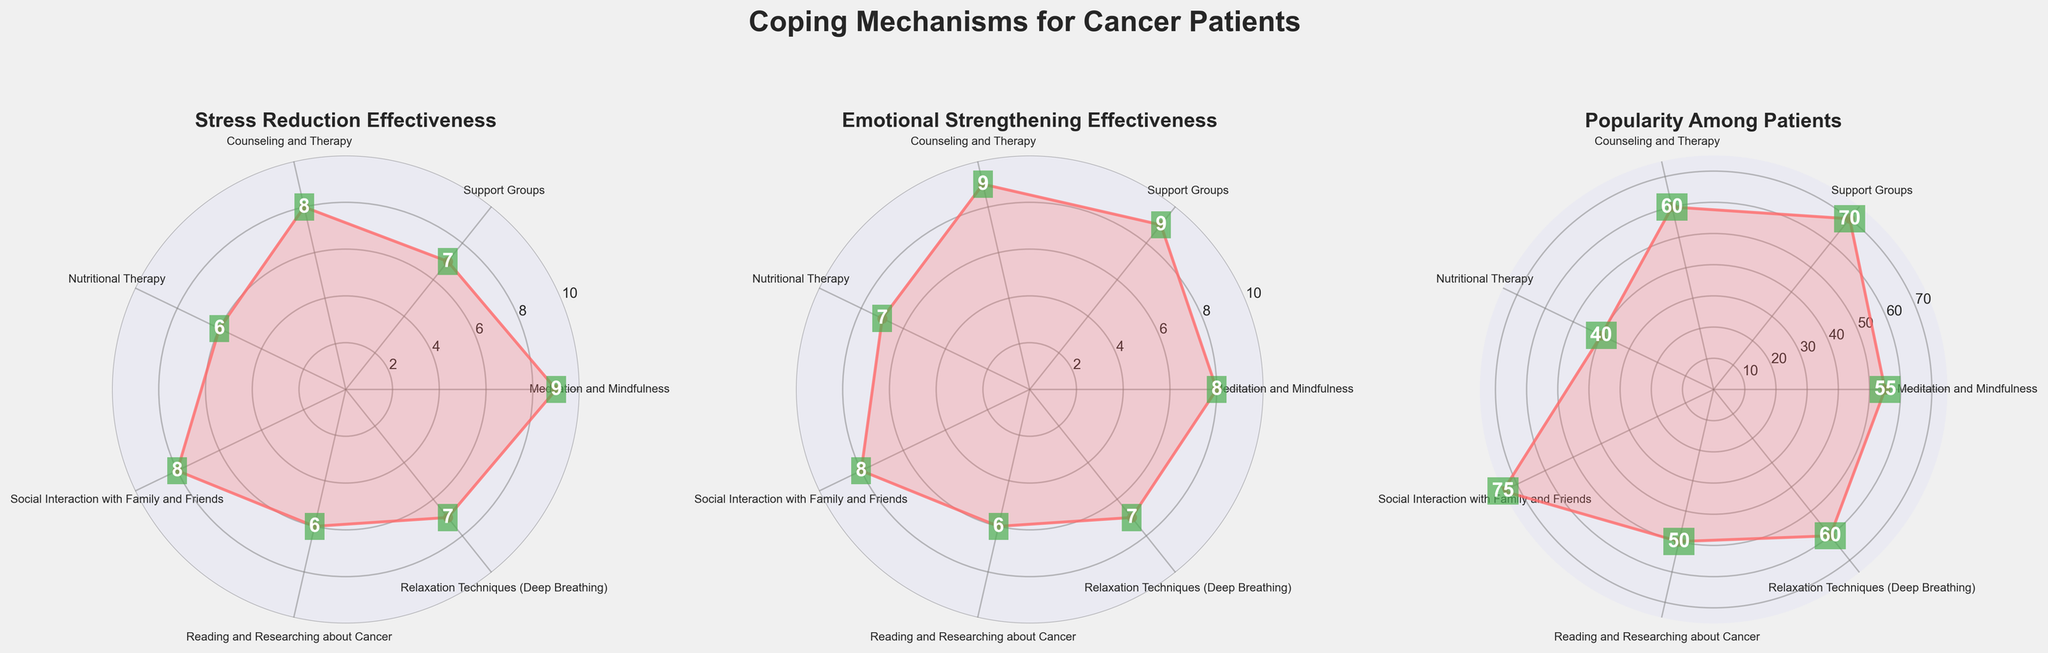What is the title of the figure? The title is displayed prominently at the top of the figure. It reads "Coping Mechanisms for Cancer Patients".
Answer: "Coping Mechanisms for Cancer Patients" Which coping mechanism has the highest effectiveness for emotional strengthening? Looking at the subplot titled "Emotional Strengthening Effectiveness", the highest value is found with Support Groups and Counseling and Therapy, both rated at 9.
Answer: Support Groups and Counseling and Therapy Which coping mechanism is the most popular among patients? Refer to the subplot titled "Popularity Among Patients". The highest value shown is for Social Interaction with Family and Friends, at 75.
Answer: Social Interaction with Family and Friends How many coping mechanisms have the same value for both stress reduction and emotional strengthening effectiveness? To find this, compare values in the "Stress Reduction Effectiveness" and "Emotional Strengthening Effectiveness" subplots. Matches are Meditation and Mindfulness (9, 8), Support Groups (7, 9), Counseling and Therapy (8, 9), Social Interaction with Family and Friends (8, 8), Reading and Researching about Cancer (6, 6), and Relaxation Techniques (Deep Breathing) (7, 7).
Answer: 3 Which coping mechanism has the lowest effectiveness for stress reduction? Looking at the "Stress Reduction Effectiveness" subplot, the lowest value is for Nutritional Therapy and Reading and Researching about Cancer, both rated at 6.
Answer: Nutritional Therapy and Reading and Researching about Cancer Is the effectiveness of Social Interaction with Family and Friends for stress reduction greater than its popularity among patients? Compare the stress reduction effectiveness value (8) with the popularity value (75). Since 8 is less than 75, the answer is no.
Answer: No What is the average effectiveness of Meditation and Mindfulness for stress reduction and emotional strengthening? The values are 9 for stress reduction and 8 for emotional strengthening. The average can be calculated as (9 + 8) / 2 = 8.5.
Answer: 8.5 Which coping mechanism ranks the same in both popularity and emotional strengthening effectiveness? Compare the "Popularity Among Patients" subplot with "Emotional Strengthening Effectiveness". Only Reading and Researching about Cancer has same value (50 popularity and 6 emotional strengthening).
Answer: Reading and Researching about Cancer Which is more effective in stress reduction: Relaxation Techniques or Nutritional Therapy? Compare the stress reduction values. Relaxation Techniques has a value of 7, while Nutritional Therapy has a value of 6. Therefore, Relaxation Techniques is more effective.
Answer: Relaxation Techniques Which coping mechanism is equally effective in emotional strengthening and stress reduction? In the "Emotional Strengthening Effectiveness" and "Stress Reduction Effectiveness" subplots, Social Interaction with Family and Friends is rated 8 for both.
Answer: Social Interaction with Family and Friends 